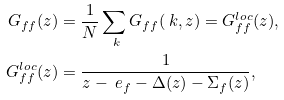<formula> <loc_0><loc_0><loc_500><loc_500>G _ { f f } ( z ) & = \frac { 1 } { N } \sum _ { \ k } G _ { f f } ( \ k , z ) = G ^ { l o c } _ { f f } ( z ) , \\ G ^ { l o c } _ { f f } ( z ) & = \frac { 1 } { z - \ e _ { f } - \Delta ( z ) - \Sigma _ { f } ( z ) } ,</formula> 